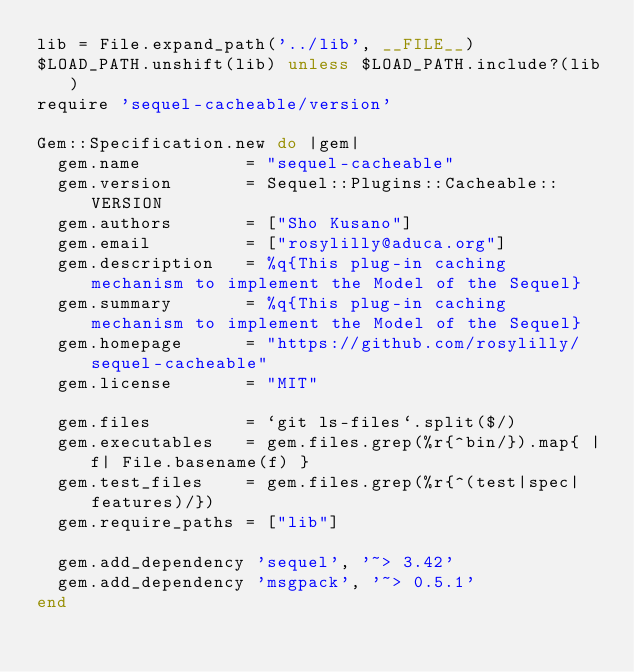<code> <loc_0><loc_0><loc_500><loc_500><_Ruby_>lib = File.expand_path('../lib', __FILE__)
$LOAD_PATH.unshift(lib) unless $LOAD_PATH.include?(lib)
require 'sequel-cacheable/version'

Gem::Specification.new do |gem|
  gem.name          = "sequel-cacheable"
  gem.version       = Sequel::Plugins::Cacheable::VERSION
  gem.authors       = ["Sho Kusano"]
  gem.email         = ["rosylilly@aduca.org"]
  gem.description   = %q{This plug-in caching mechanism to implement the Model of the Sequel}
  gem.summary       = %q{This plug-in caching mechanism to implement the Model of the Sequel}
  gem.homepage      = "https://github.com/rosylilly/sequel-cacheable"
  gem.license       = "MIT"

  gem.files         = `git ls-files`.split($/)
  gem.executables   = gem.files.grep(%r{^bin/}).map{ |f| File.basename(f) }
  gem.test_files    = gem.files.grep(%r{^(test|spec|features)/})
  gem.require_paths = ["lib"]

  gem.add_dependency 'sequel', '~> 3.42'
  gem.add_dependency 'msgpack', '~> 0.5.1'
end
</code> 